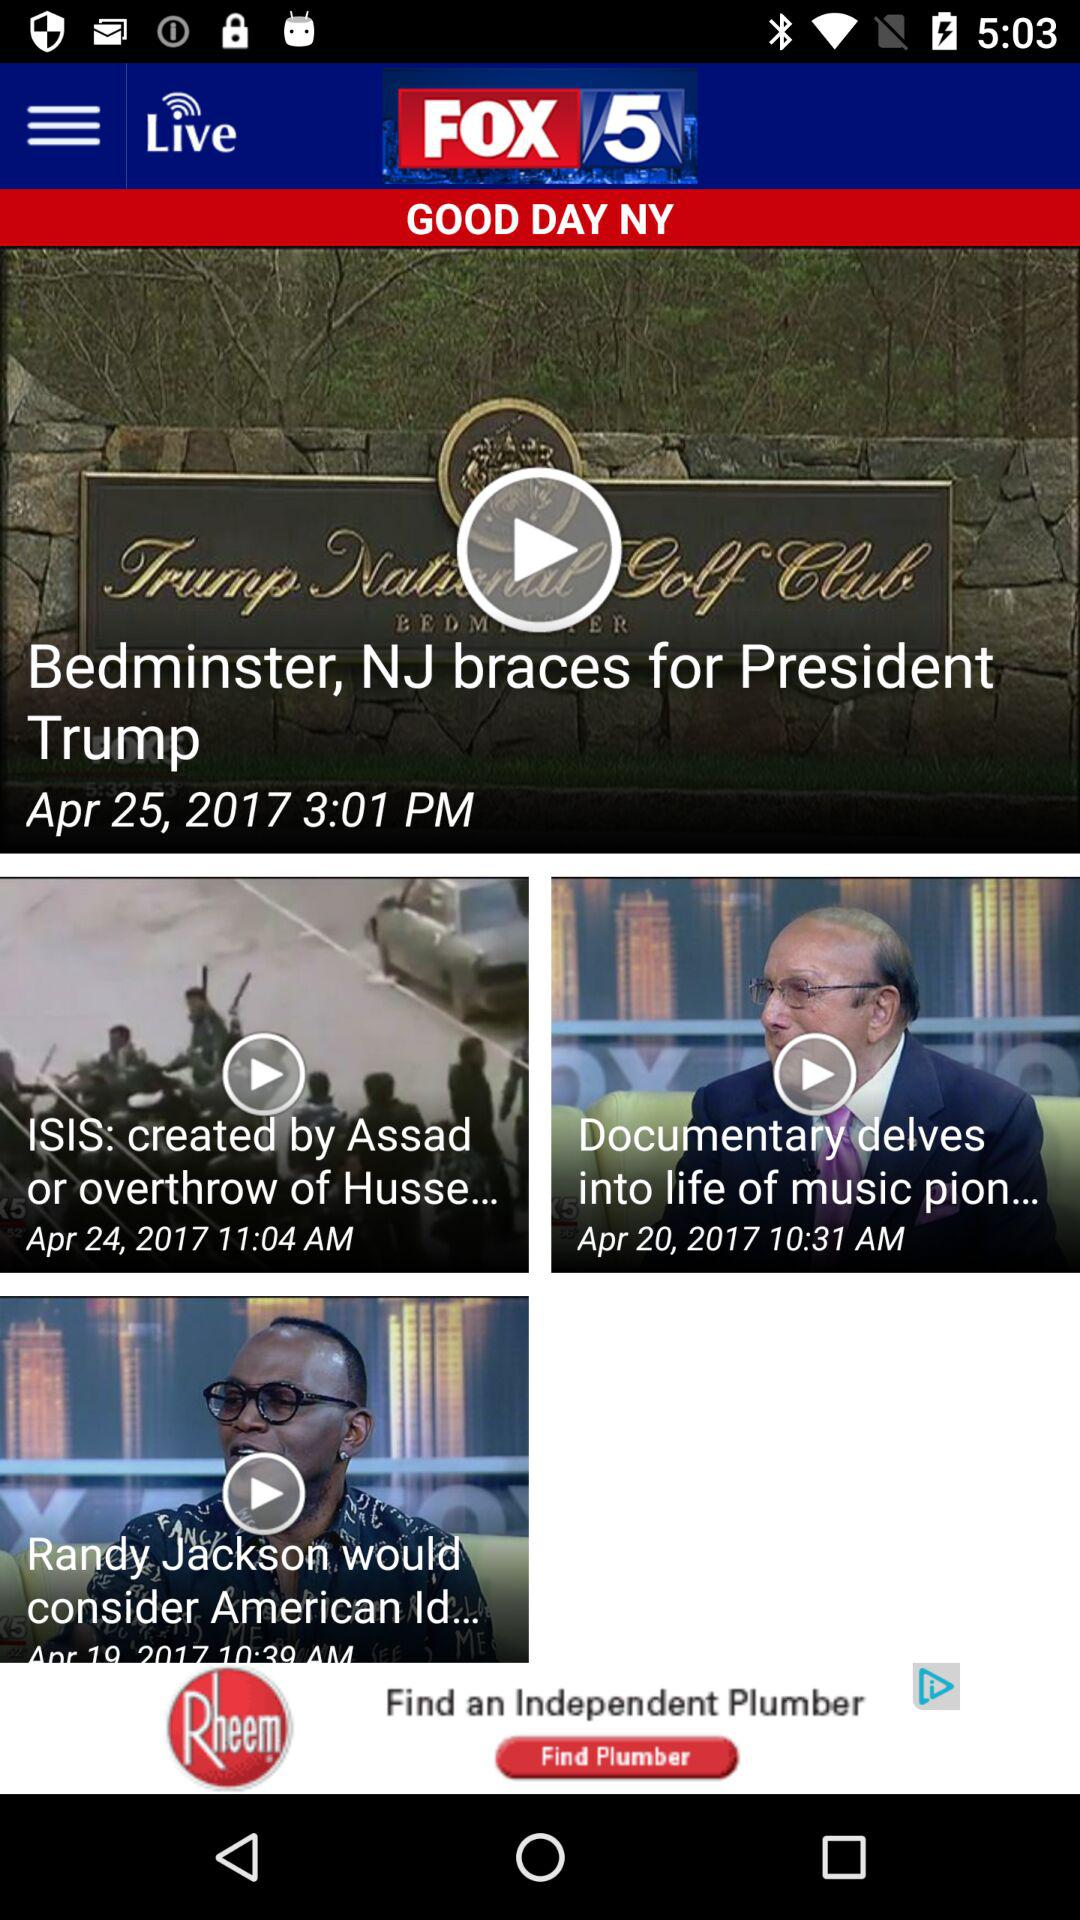When was "Documentary delves into life of music pion..." posted? It was posted on April 20, 2017. 